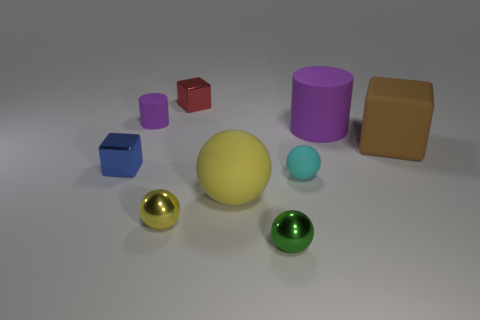Subtract all blue blocks. How many blocks are left? 2 Add 1 big gray things. How many objects exist? 10 Subtract all green spheres. How many spheres are left? 3 Subtract all balls. How many objects are left? 5 Subtract 4 spheres. How many spheres are left? 0 Add 2 brown matte balls. How many brown matte balls exist? 2 Subtract 0 purple cubes. How many objects are left? 9 Subtract all gray cylinders. Subtract all gray cubes. How many cylinders are left? 2 Subtract all gray cylinders. How many purple balls are left? 0 Subtract all green matte blocks. Subtract all tiny blocks. How many objects are left? 7 